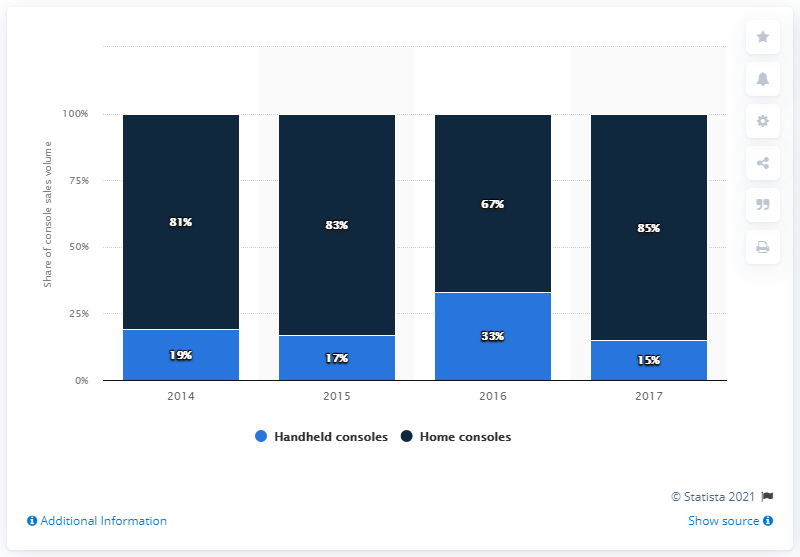Outline some significant characteristics in this image. The blue bar indicates handheld consoles. The average of home consoles is 81.25. 